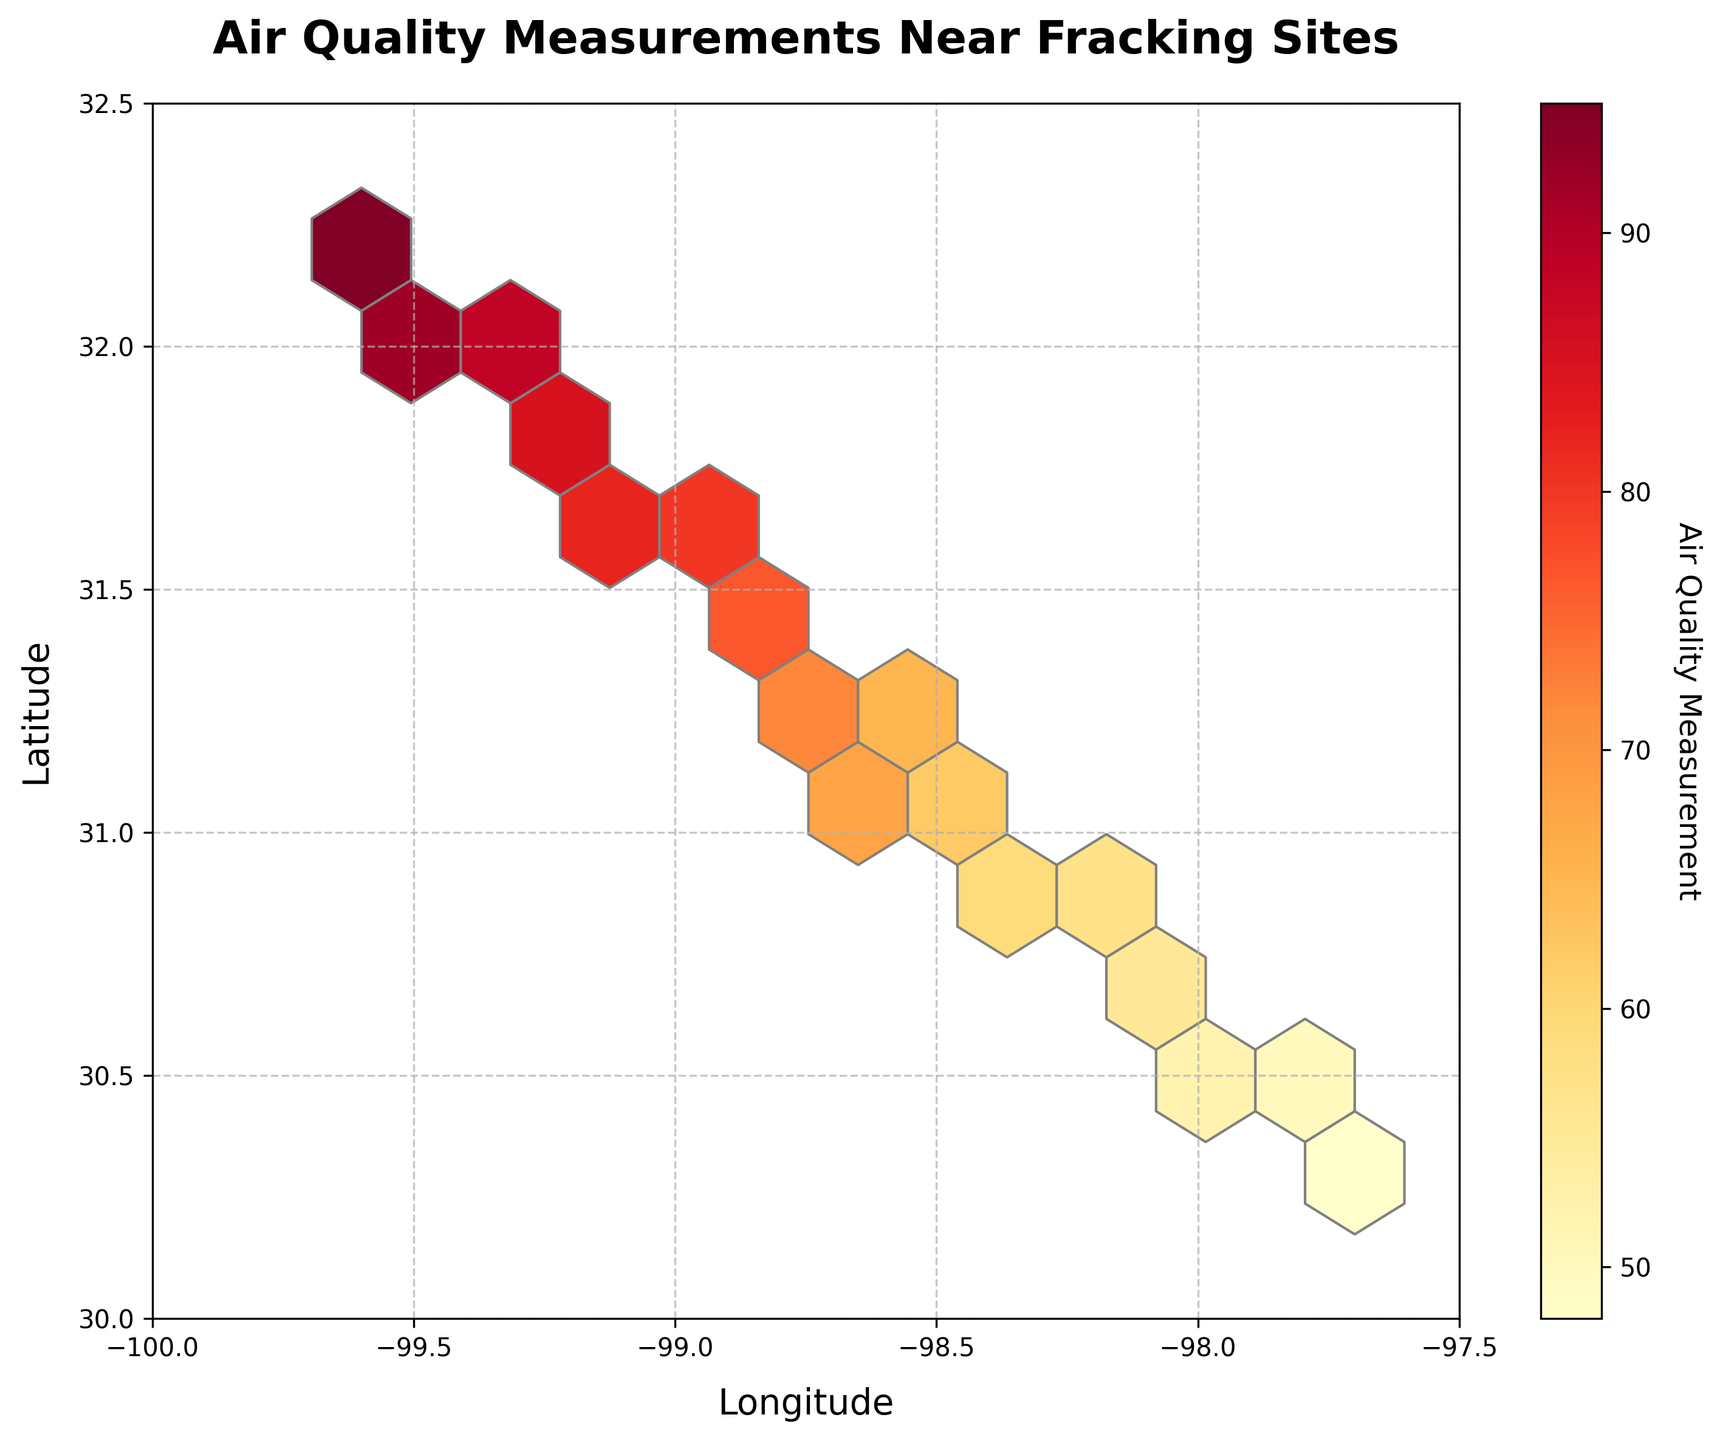Did the plot have any grid lines? Yes, there are grid lines in the plot. The grid lines help in identifying the coordinates more precisely.
Answer: Yes What is the title of the plot? The title indicates what the plot is depicting. In this case, it's "Air Quality Measurements Near Fracking Sites."
Answer: Air Quality Measurements Near Fracking Sites Which axis represents longitude? The x-axis represents the horizontal component and shows the geographical longitude.
Answer: x-axis What is the range of latitude values shown on the y-axis? The y-axis has a range that represents the latitude values. In the plot, latitude values range from 30 to 32.5.
Answer: 30 to 32.5 What color scheme is used in the plot? The color scheme is used to depict different air quality measurements. The plot uses shades from yellow to red, where lighter colors (yellow) represent lower measurements and darker colors (red) indicate higher measurements.
Answer: Yellow to Red Which areas had the highest air quality measurements? Areas with darker hexagons (red) indicate higher air quality measurements. These areas are concentrated in the northeastern part of the plot.
Answer: Northeastern areas How does air quality measurement change with location? By observing the plot, air quality measurements increase or darken (yellow to red) as you move from southwest to northeast.
Answer: Increase from southwest to northeast Compare the air quality in the southwestern and northeastern corners of the plot. The southwestern corner has lighter hexagons (lower air quality measurements) compared to the northeastern corner, which has darker hexagons (higher air quality measurements).
Answer: Northeastern is higher What's the grid size used in the hexbin plot? A grid size is chosen to divide the area into small hexagonal bins. The plot uses a grid size of 10, as illustrated by the number of bins in both directions.
Answer: 10 What information does the color bar provide? The color bar indicates the range and levels of air quality measurements, from the lowest (light yellow) to the highest (dark red).
Answer: Air quality measurement levels 